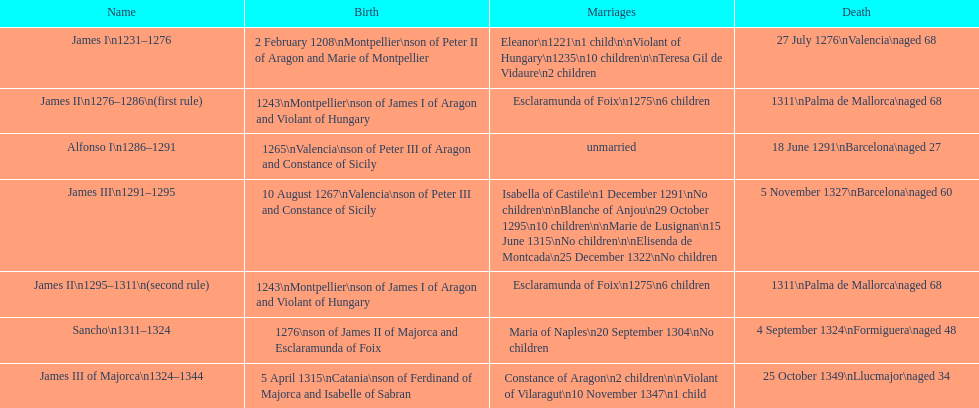What is the name that comes after james ii and before james iii? Alfonso I. 